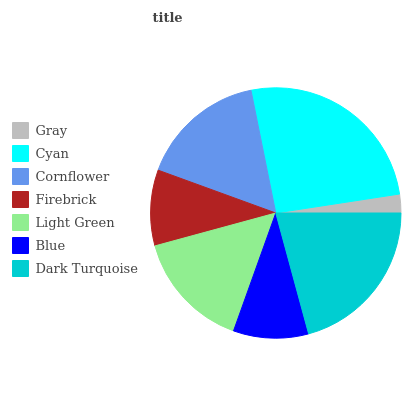Is Gray the minimum?
Answer yes or no. Yes. Is Cyan the maximum?
Answer yes or no. Yes. Is Cornflower the minimum?
Answer yes or no. No. Is Cornflower the maximum?
Answer yes or no. No. Is Cyan greater than Cornflower?
Answer yes or no. Yes. Is Cornflower less than Cyan?
Answer yes or no. Yes. Is Cornflower greater than Cyan?
Answer yes or no. No. Is Cyan less than Cornflower?
Answer yes or no. No. Is Light Green the high median?
Answer yes or no. Yes. Is Light Green the low median?
Answer yes or no. Yes. Is Cornflower the high median?
Answer yes or no. No. Is Dark Turquoise the low median?
Answer yes or no. No. 